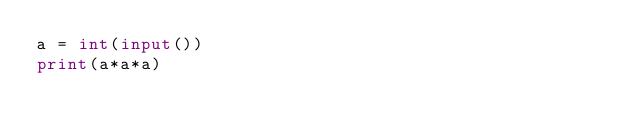Convert code to text. <code><loc_0><loc_0><loc_500><loc_500><_Python_>a = int(input())
print(a*a*a)
</code> 